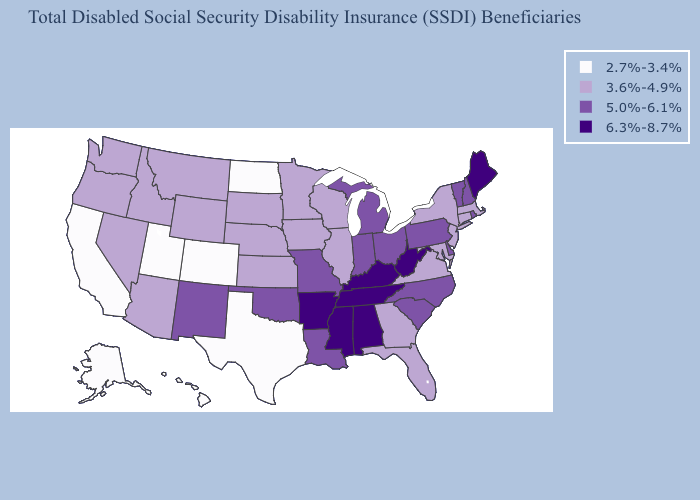Name the states that have a value in the range 6.3%-8.7%?
Short answer required. Alabama, Arkansas, Kentucky, Maine, Mississippi, Tennessee, West Virginia. What is the lowest value in the Northeast?
Concise answer only. 3.6%-4.9%. What is the value of Alaska?
Short answer required. 2.7%-3.4%. Does Delaware have a lower value than Mississippi?
Be succinct. Yes. How many symbols are there in the legend?
Give a very brief answer. 4. How many symbols are there in the legend?
Short answer required. 4. Name the states that have a value in the range 5.0%-6.1%?
Short answer required. Delaware, Indiana, Louisiana, Michigan, Missouri, New Hampshire, New Mexico, North Carolina, Ohio, Oklahoma, Pennsylvania, Rhode Island, South Carolina, Vermont. Which states hav the highest value in the West?
Concise answer only. New Mexico. Does New Hampshire have the same value as New Mexico?
Short answer required. Yes. Does Rhode Island have the same value as Colorado?
Be succinct. No. What is the lowest value in states that border Florida?
Short answer required. 3.6%-4.9%. Does New Jersey have a higher value than California?
Answer briefly. Yes. Does the first symbol in the legend represent the smallest category?
Keep it brief. Yes. What is the highest value in the USA?
Give a very brief answer. 6.3%-8.7%. What is the lowest value in the USA?
Be succinct. 2.7%-3.4%. 